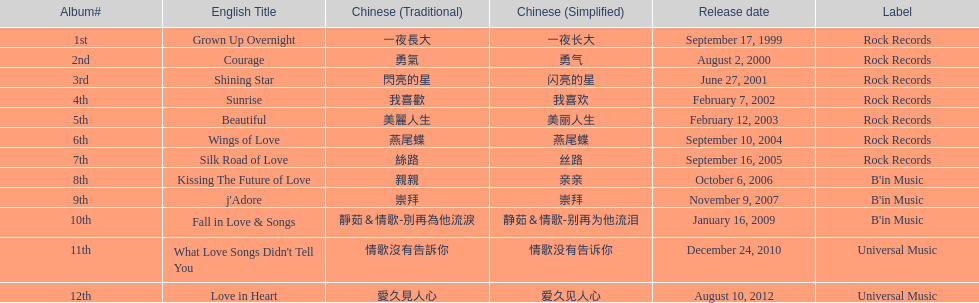Which song is listed first in the table? Grown Up Overnight. 